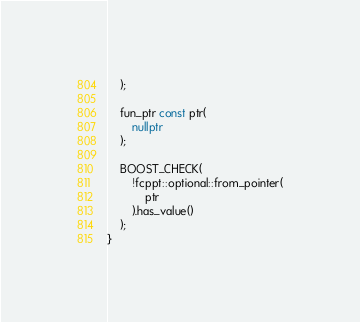Convert code to text. <code><loc_0><loc_0><loc_500><loc_500><_C++_>	);

	fun_ptr const ptr(
		nullptr
	);

	BOOST_CHECK(
		!fcppt::optional::from_pointer(
			ptr
		).has_value()
	);
}
</code> 